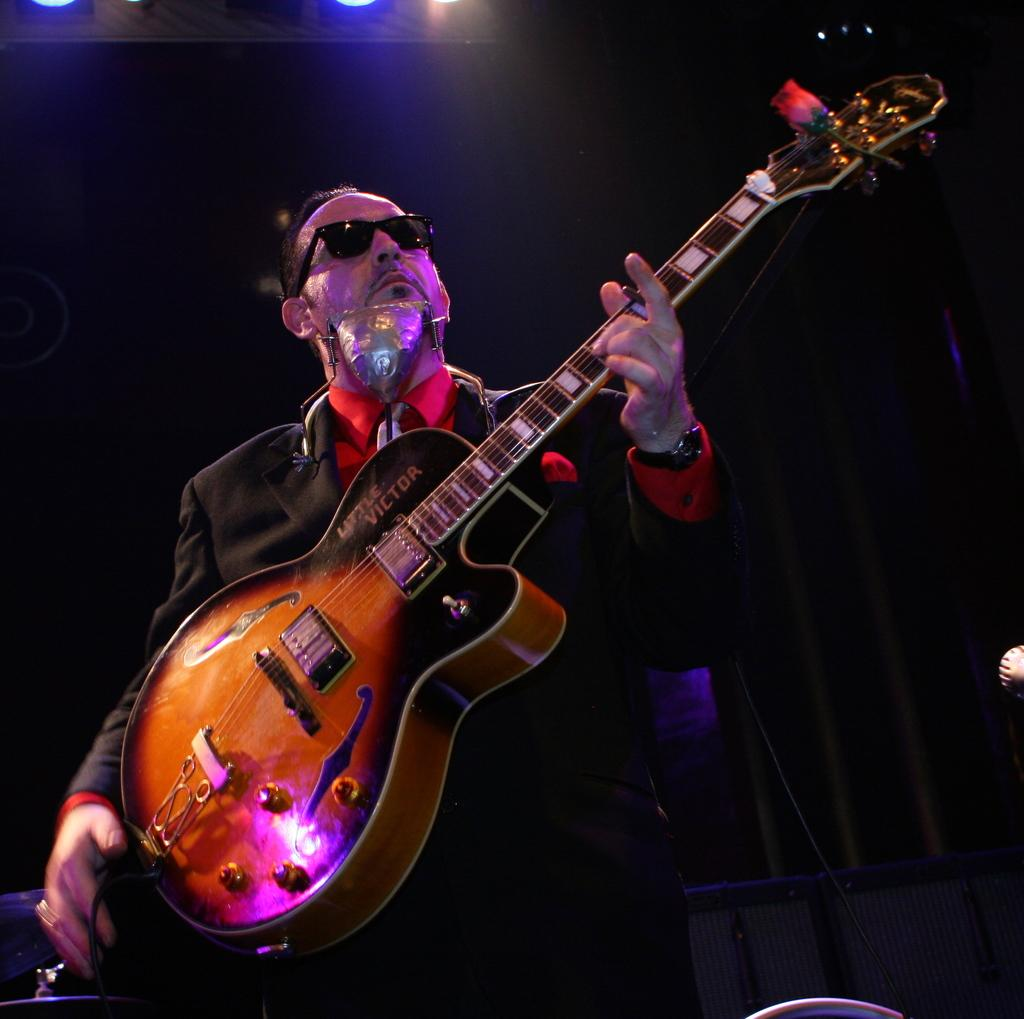What is the person in the image doing? The person is standing in the image and holding a musical instrument. What type of clothing is the person wearing? The person is wearing a black blazer and a red shirt. What can be seen in the background of the image? There are lights visible in the background of the image. What type of bell can be heard ringing in the image? There is no bell present in the image, and therefore no sound can be heard. 